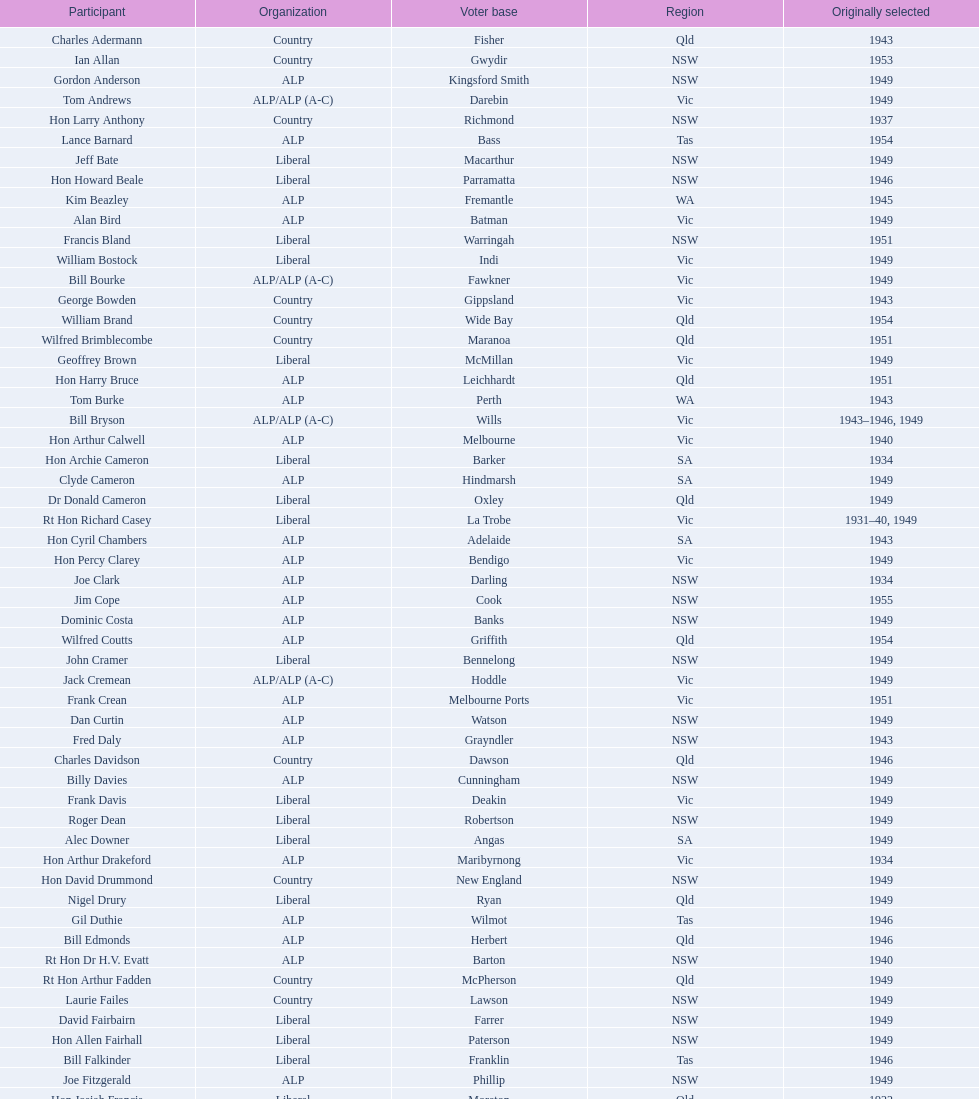Did tom burke run as country or alp party? ALP. 